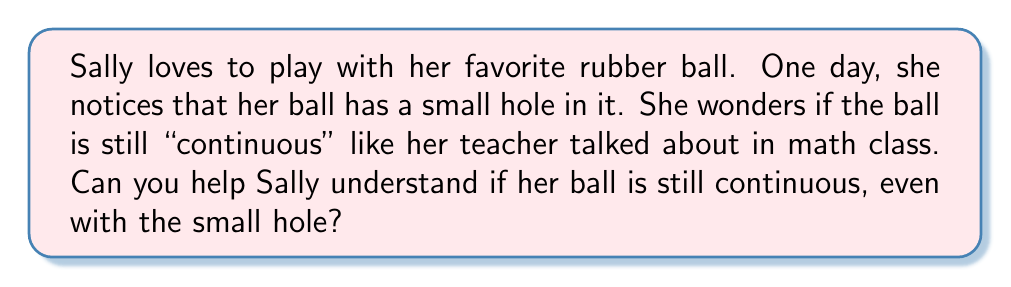Help me with this question. This is a great question to help understand continuity in everyday objects! Let's break it down step by step:

1. In topology, continuity refers to the idea that an object has no breaks or interruptions in its surface.

2. A perfect sphere, like Sally's ball before it got the hole, is a continuous object. We can trace a path along its surface without ever lifting our finger.

3. When Sally's ball gets a small hole, it might seem like it's no longer continuous. However, from a topological perspective, it still is!

4. Imagine the ball is made of a very stretchy material. We can stretch the edges of the hole and connect them, closing the gap without creating any new holes or tears.

5. Mathematically, we can represent this idea using a continuous function $f: S^2 \rightarrow X$, where $S^2$ is a sphere and $X$ is Sally's ball with a hole. This function would map every point on the sphere to a corresponding point on Sally's ball.

6. The key is that this mapping can be done without any "jumps" or discontinuities. Every nearby point on the sphere maps to a nearby point on Sally's ball.

7. In topology, objects that can be transformed into each other through stretching, bending, or squishing (but not tearing or gluing) are considered topologically equivalent or homeomorphic.

8. A sphere and a ball with a small hole are topologically equivalent to each other, and also to other shapes like a coffee mug with a handle!

This concept helps us understand that continuity in topology is about the fundamental shape and connectivity of an object, not its exact geometry.
Answer: Yes, Sally's ball is still considered continuous in a topological sense, even with the small hole. 